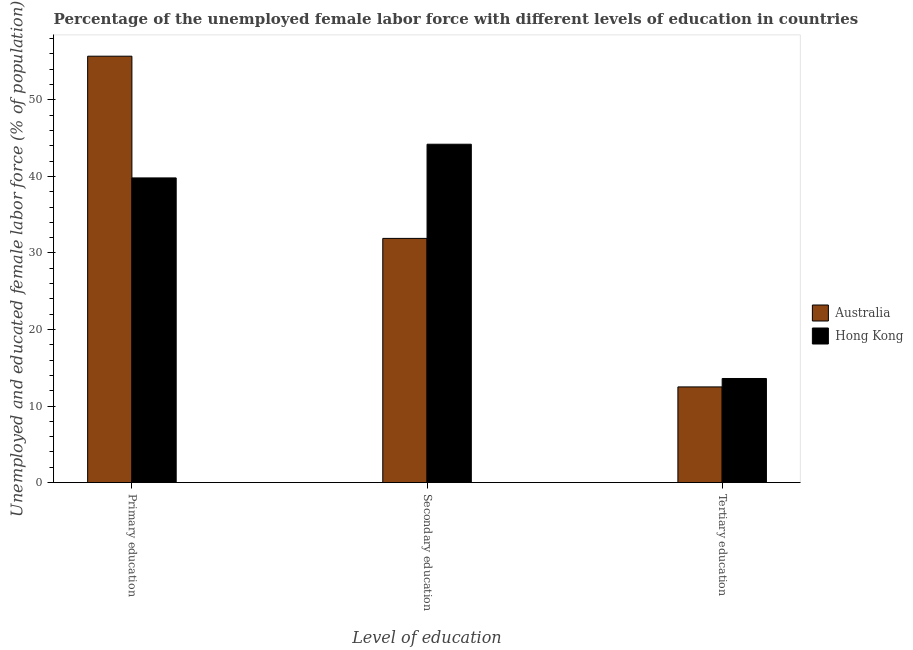How many bars are there on the 3rd tick from the left?
Offer a very short reply. 2. How many bars are there on the 1st tick from the right?
Offer a terse response. 2. What is the label of the 3rd group of bars from the left?
Your response must be concise. Tertiary education. What is the percentage of female labor force who received tertiary education in Hong Kong?
Offer a terse response. 13.6. Across all countries, what is the maximum percentage of female labor force who received secondary education?
Keep it short and to the point. 44.2. Across all countries, what is the minimum percentage of female labor force who received secondary education?
Your answer should be very brief. 31.9. In which country was the percentage of female labor force who received tertiary education maximum?
Make the answer very short. Hong Kong. What is the total percentage of female labor force who received primary education in the graph?
Your answer should be compact. 95.5. What is the difference between the percentage of female labor force who received tertiary education in Australia and that in Hong Kong?
Make the answer very short. -1.1. What is the difference between the percentage of female labor force who received tertiary education in Hong Kong and the percentage of female labor force who received secondary education in Australia?
Offer a very short reply. -18.3. What is the average percentage of female labor force who received primary education per country?
Keep it short and to the point. 47.75. What is the difference between the percentage of female labor force who received primary education and percentage of female labor force who received secondary education in Hong Kong?
Provide a succinct answer. -4.4. In how many countries, is the percentage of female labor force who received primary education greater than 2 %?
Offer a very short reply. 2. What is the ratio of the percentage of female labor force who received primary education in Hong Kong to that in Australia?
Your answer should be very brief. 0.71. Is the difference between the percentage of female labor force who received primary education in Australia and Hong Kong greater than the difference between the percentage of female labor force who received tertiary education in Australia and Hong Kong?
Provide a succinct answer. Yes. What is the difference between the highest and the second highest percentage of female labor force who received tertiary education?
Keep it short and to the point. 1.1. What is the difference between the highest and the lowest percentage of female labor force who received tertiary education?
Provide a short and direct response. 1.1. What does the 2nd bar from the left in Primary education represents?
Give a very brief answer. Hong Kong. Is it the case that in every country, the sum of the percentage of female labor force who received primary education and percentage of female labor force who received secondary education is greater than the percentage of female labor force who received tertiary education?
Your answer should be compact. Yes. Are all the bars in the graph horizontal?
Offer a very short reply. No. How many countries are there in the graph?
Ensure brevity in your answer.  2. Are the values on the major ticks of Y-axis written in scientific E-notation?
Your answer should be compact. No. Does the graph contain any zero values?
Ensure brevity in your answer.  No. Does the graph contain grids?
Your answer should be very brief. No. How many legend labels are there?
Give a very brief answer. 2. What is the title of the graph?
Your answer should be compact. Percentage of the unemployed female labor force with different levels of education in countries. What is the label or title of the X-axis?
Make the answer very short. Level of education. What is the label or title of the Y-axis?
Give a very brief answer. Unemployed and educated female labor force (% of population). What is the Unemployed and educated female labor force (% of population) in Australia in Primary education?
Provide a succinct answer. 55.7. What is the Unemployed and educated female labor force (% of population) of Hong Kong in Primary education?
Ensure brevity in your answer.  39.8. What is the Unemployed and educated female labor force (% of population) in Australia in Secondary education?
Give a very brief answer. 31.9. What is the Unemployed and educated female labor force (% of population) of Hong Kong in Secondary education?
Ensure brevity in your answer.  44.2. What is the Unemployed and educated female labor force (% of population) in Hong Kong in Tertiary education?
Your answer should be very brief. 13.6. Across all Level of education, what is the maximum Unemployed and educated female labor force (% of population) of Australia?
Keep it short and to the point. 55.7. Across all Level of education, what is the maximum Unemployed and educated female labor force (% of population) of Hong Kong?
Ensure brevity in your answer.  44.2. Across all Level of education, what is the minimum Unemployed and educated female labor force (% of population) of Hong Kong?
Ensure brevity in your answer.  13.6. What is the total Unemployed and educated female labor force (% of population) in Australia in the graph?
Make the answer very short. 100.1. What is the total Unemployed and educated female labor force (% of population) in Hong Kong in the graph?
Your answer should be very brief. 97.6. What is the difference between the Unemployed and educated female labor force (% of population) in Australia in Primary education and that in Secondary education?
Offer a terse response. 23.8. What is the difference between the Unemployed and educated female labor force (% of population) of Hong Kong in Primary education and that in Secondary education?
Offer a very short reply. -4.4. What is the difference between the Unemployed and educated female labor force (% of population) in Australia in Primary education and that in Tertiary education?
Ensure brevity in your answer.  43.2. What is the difference between the Unemployed and educated female labor force (% of population) in Hong Kong in Primary education and that in Tertiary education?
Give a very brief answer. 26.2. What is the difference between the Unemployed and educated female labor force (% of population) in Australia in Secondary education and that in Tertiary education?
Offer a terse response. 19.4. What is the difference between the Unemployed and educated female labor force (% of population) in Hong Kong in Secondary education and that in Tertiary education?
Make the answer very short. 30.6. What is the difference between the Unemployed and educated female labor force (% of population) in Australia in Primary education and the Unemployed and educated female labor force (% of population) in Hong Kong in Tertiary education?
Offer a terse response. 42.1. What is the average Unemployed and educated female labor force (% of population) in Australia per Level of education?
Provide a short and direct response. 33.37. What is the average Unemployed and educated female labor force (% of population) in Hong Kong per Level of education?
Provide a short and direct response. 32.53. What is the ratio of the Unemployed and educated female labor force (% of population) of Australia in Primary education to that in Secondary education?
Keep it short and to the point. 1.75. What is the ratio of the Unemployed and educated female labor force (% of population) of Hong Kong in Primary education to that in Secondary education?
Offer a very short reply. 0.9. What is the ratio of the Unemployed and educated female labor force (% of population) in Australia in Primary education to that in Tertiary education?
Your response must be concise. 4.46. What is the ratio of the Unemployed and educated female labor force (% of population) of Hong Kong in Primary education to that in Tertiary education?
Your answer should be compact. 2.93. What is the ratio of the Unemployed and educated female labor force (% of population) of Australia in Secondary education to that in Tertiary education?
Provide a short and direct response. 2.55. What is the ratio of the Unemployed and educated female labor force (% of population) of Hong Kong in Secondary education to that in Tertiary education?
Keep it short and to the point. 3.25. What is the difference between the highest and the second highest Unemployed and educated female labor force (% of population) of Australia?
Provide a short and direct response. 23.8. What is the difference between the highest and the lowest Unemployed and educated female labor force (% of population) of Australia?
Your answer should be compact. 43.2. What is the difference between the highest and the lowest Unemployed and educated female labor force (% of population) in Hong Kong?
Offer a terse response. 30.6. 